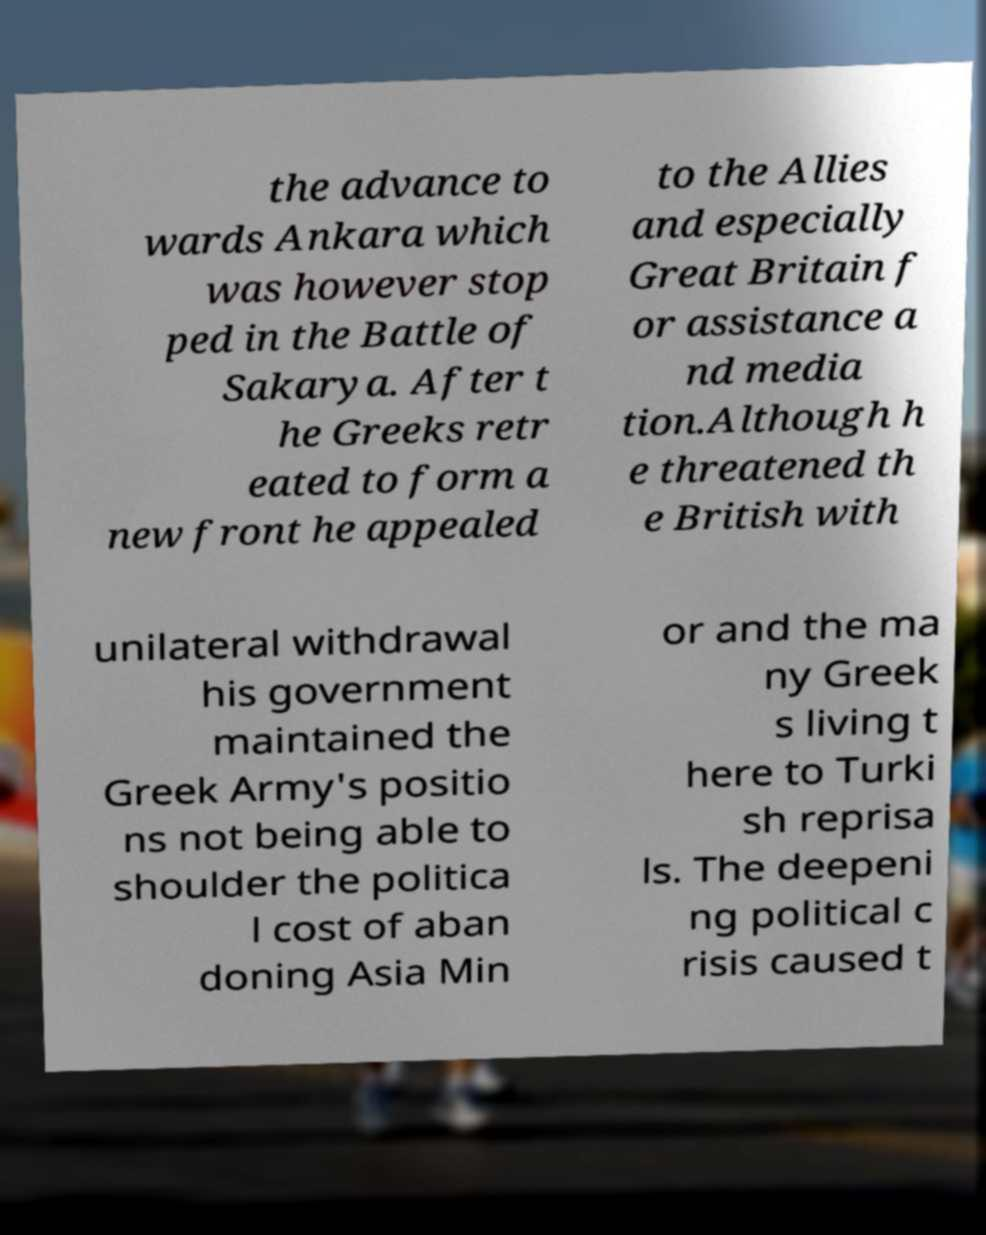What messages or text are displayed in this image? I need them in a readable, typed format. the advance to wards Ankara which was however stop ped in the Battle of Sakarya. After t he Greeks retr eated to form a new front he appealed to the Allies and especially Great Britain f or assistance a nd media tion.Although h e threatened th e British with unilateral withdrawal his government maintained the Greek Army's positio ns not being able to shoulder the politica l cost of aban doning Asia Min or and the ma ny Greek s living t here to Turki sh reprisa ls. The deepeni ng political c risis caused t 